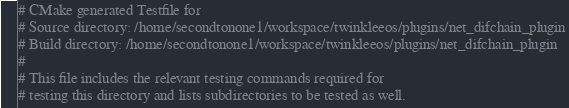<code> <loc_0><loc_0><loc_500><loc_500><_CMake_># CMake generated Testfile for 
# Source directory: /home/secondtonone1/workspace/twinkleeos/plugins/net_difchain_plugin
# Build directory: /home/secondtonone1/workspace/twinkleeos/plugins/net_difchain_plugin
# 
# This file includes the relevant testing commands required for 
# testing this directory and lists subdirectories to be tested as well.
</code> 